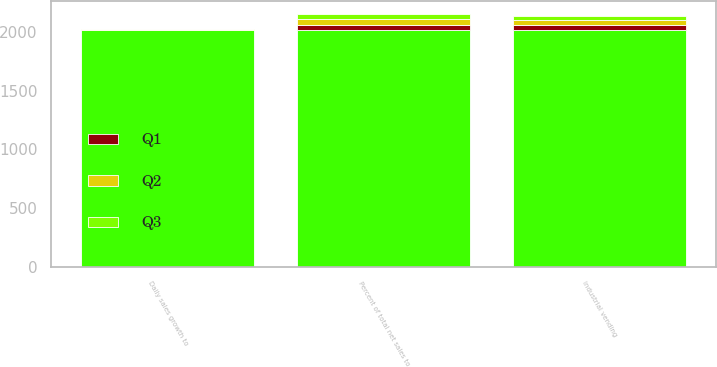Convert chart. <chart><loc_0><loc_0><loc_500><loc_500><stacked_bar_chart><ecel><fcel>Percent of total net sales to<fcel>industrial vending<fcel>Daily sales growth to<nl><fcel>nan<fcel>2016<fcel>2015<fcel>2016<nl><fcel>Q3<fcel>44.5<fcel>40.5<fcel>3.6<nl><fcel>Q1<fcel>44.6<fcel>40.9<fcel>2.7<nl><fcel>Q2<fcel>45<fcel>42.1<fcel>2.4<nl></chart> 